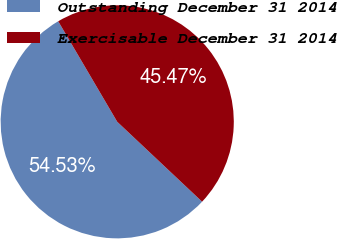Convert chart to OTSL. <chart><loc_0><loc_0><loc_500><loc_500><pie_chart><fcel>Outstanding December 31 2014<fcel>Exercisable December 31 2014<nl><fcel>54.53%<fcel>45.47%<nl></chart> 